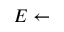Convert formula to latex. <formula><loc_0><loc_0><loc_500><loc_500>E \gets</formula> 